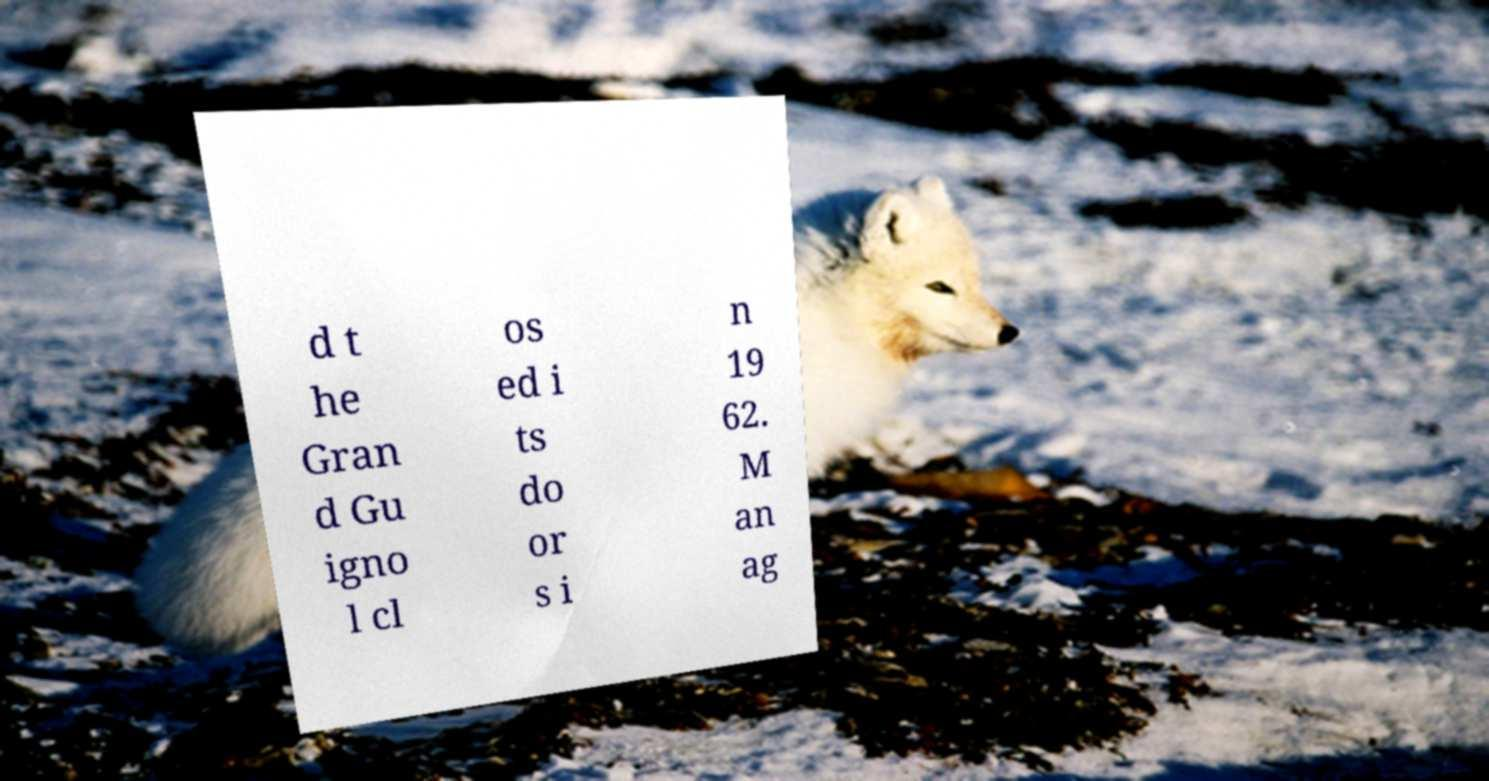Can you read and provide the text displayed in the image?This photo seems to have some interesting text. Can you extract and type it out for me? d t he Gran d Gu igno l cl os ed i ts do or s i n 19 62. M an ag 